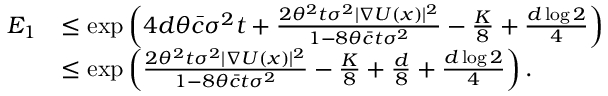<formula> <loc_0><loc_0><loc_500><loc_500>\begin{array} { r l } { E _ { 1 } } & { \leq \exp \left ( 4 d \theta \bar { c } \sigma ^ { 2 } t + \frac { 2 \theta ^ { 2 } t \sigma ^ { 2 } | \nabla U ( x ) | ^ { 2 } } { 1 - 8 \theta \bar { c } t \sigma ^ { 2 } } - \frac { K } { 8 } + \frac { d \log 2 } { 4 } \right ) } \\ & { \leq \exp \left ( \frac { 2 \theta ^ { 2 } t \sigma ^ { 2 } | \nabla U ( x ) | ^ { 2 } } { 1 - 8 \theta \bar { c } t \sigma ^ { 2 } } - \frac { K } { 8 } + \frac { d } { 8 } + \frac { d \log 2 } { 4 } \right ) . } \end{array}</formula> 